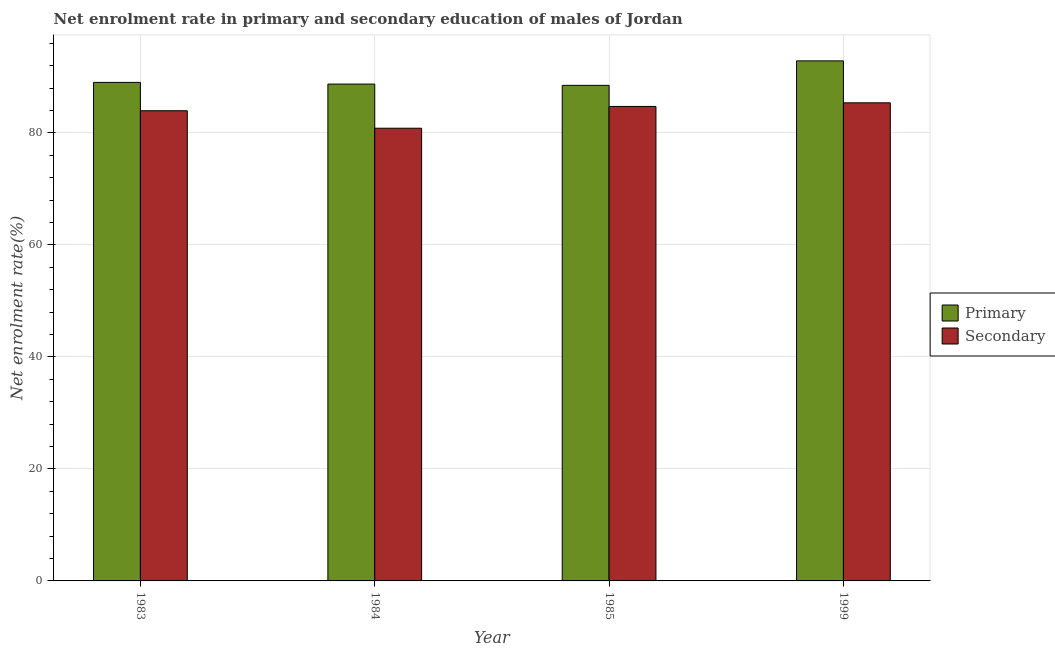How many different coloured bars are there?
Your answer should be compact. 2. Are the number of bars per tick equal to the number of legend labels?
Provide a short and direct response. Yes. What is the enrollment rate in primary education in 1984?
Ensure brevity in your answer.  88.72. Across all years, what is the maximum enrollment rate in secondary education?
Ensure brevity in your answer.  85.38. Across all years, what is the minimum enrollment rate in primary education?
Your response must be concise. 88.5. In which year was the enrollment rate in primary education maximum?
Ensure brevity in your answer.  1999. In which year was the enrollment rate in secondary education minimum?
Ensure brevity in your answer.  1984. What is the total enrollment rate in primary education in the graph?
Provide a short and direct response. 359.11. What is the difference between the enrollment rate in secondary education in 1983 and that in 1984?
Offer a very short reply. 3.12. What is the difference between the enrollment rate in primary education in 1984 and the enrollment rate in secondary education in 1983?
Your answer should be compact. -0.3. What is the average enrollment rate in secondary education per year?
Ensure brevity in your answer.  83.73. In how many years, is the enrollment rate in primary education greater than 92 %?
Ensure brevity in your answer.  1. What is the ratio of the enrollment rate in secondary education in 1984 to that in 1999?
Keep it short and to the point. 0.95. Is the difference between the enrollment rate in secondary education in 1983 and 1984 greater than the difference between the enrollment rate in primary education in 1983 and 1984?
Your answer should be compact. No. What is the difference between the highest and the second highest enrollment rate in secondary education?
Your response must be concise. 0.65. What is the difference between the highest and the lowest enrollment rate in primary education?
Make the answer very short. 4.37. In how many years, is the enrollment rate in secondary education greater than the average enrollment rate in secondary education taken over all years?
Offer a very short reply. 3. What does the 1st bar from the left in 1983 represents?
Provide a short and direct response. Primary. What does the 2nd bar from the right in 1983 represents?
Keep it short and to the point. Primary. How many bars are there?
Provide a succinct answer. 8. What is the difference between two consecutive major ticks on the Y-axis?
Your response must be concise. 20. Does the graph contain grids?
Offer a very short reply. Yes. How many legend labels are there?
Give a very brief answer. 2. What is the title of the graph?
Give a very brief answer. Net enrolment rate in primary and secondary education of males of Jordan. Does "Highest 10% of population" appear as one of the legend labels in the graph?
Ensure brevity in your answer.  No. What is the label or title of the X-axis?
Provide a short and direct response. Year. What is the label or title of the Y-axis?
Ensure brevity in your answer.  Net enrolment rate(%). What is the Net enrolment rate(%) of Primary in 1983?
Your answer should be very brief. 89.03. What is the Net enrolment rate(%) in Secondary in 1983?
Your answer should be very brief. 83.96. What is the Net enrolment rate(%) of Primary in 1984?
Keep it short and to the point. 88.72. What is the Net enrolment rate(%) in Secondary in 1984?
Make the answer very short. 80.84. What is the Net enrolment rate(%) of Primary in 1985?
Provide a succinct answer. 88.5. What is the Net enrolment rate(%) in Secondary in 1985?
Offer a very short reply. 84.73. What is the Net enrolment rate(%) in Primary in 1999?
Make the answer very short. 92.87. What is the Net enrolment rate(%) of Secondary in 1999?
Your response must be concise. 85.38. Across all years, what is the maximum Net enrolment rate(%) of Primary?
Give a very brief answer. 92.87. Across all years, what is the maximum Net enrolment rate(%) of Secondary?
Make the answer very short. 85.38. Across all years, what is the minimum Net enrolment rate(%) in Primary?
Provide a succinct answer. 88.5. Across all years, what is the minimum Net enrolment rate(%) in Secondary?
Ensure brevity in your answer.  80.84. What is the total Net enrolment rate(%) in Primary in the graph?
Offer a terse response. 359.11. What is the total Net enrolment rate(%) of Secondary in the graph?
Keep it short and to the point. 334.91. What is the difference between the Net enrolment rate(%) of Primary in 1983 and that in 1984?
Your answer should be compact. 0.3. What is the difference between the Net enrolment rate(%) in Secondary in 1983 and that in 1984?
Offer a very short reply. 3.12. What is the difference between the Net enrolment rate(%) in Primary in 1983 and that in 1985?
Your answer should be very brief. 0.53. What is the difference between the Net enrolment rate(%) of Secondary in 1983 and that in 1985?
Make the answer very short. -0.77. What is the difference between the Net enrolment rate(%) of Primary in 1983 and that in 1999?
Keep it short and to the point. -3.84. What is the difference between the Net enrolment rate(%) of Secondary in 1983 and that in 1999?
Your response must be concise. -1.41. What is the difference between the Net enrolment rate(%) in Primary in 1984 and that in 1985?
Your response must be concise. 0.23. What is the difference between the Net enrolment rate(%) of Secondary in 1984 and that in 1985?
Provide a short and direct response. -3.89. What is the difference between the Net enrolment rate(%) in Primary in 1984 and that in 1999?
Your answer should be compact. -4.14. What is the difference between the Net enrolment rate(%) of Secondary in 1984 and that in 1999?
Provide a short and direct response. -4.54. What is the difference between the Net enrolment rate(%) in Primary in 1985 and that in 1999?
Offer a terse response. -4.37. What is the difference between the Net enrolment rate(%) in Secondary in 1985 and that in 1999?
Ensure brevity in your answer.  -0.65. What is the difference between the Net enrolment rate(%) of Primary in 1983 and the Net enrolment rate(%) of Secondary in 1984?
Make the answer very short. 8.19. What is the difference between the Net enrolment rate(%) in Primary in 1983 and the Net enrolment rate(%) in Secondary in 1985?
Provide a succinct answer. 4.3. What is the difference between the Net enrolment rate(%) in Primary in 1983 and the Net enrolment rate(%) in Secondary in 1999?
Ensure brevity in your answer.  3.65. What is the difference between the Net enrolment rate(%) of Primary in 1984 and the Net enrolment rate(%) of Secondary in 1985?
Make the answer very short. 3.99. What is the difference between the Net enrolment rate(%) of Primary in 1984 and the Net enrolment rate(%) of Secondary in 1999?
Provide a succinct answer. 3.35. What is the difference between the Net enrolment rate(%) in Primary in 1985 and the Net enrolment rate(%) in Secondary in 1999?
Offer a terse response. 3.12. What is the average Net enrolment rate(%) of Primary per year?
Provide a short and direct response. 89.78. What is the average Net enrolment rate(%) of Secondary per year?
Your answer should be very brief. 83.73. In the year 1983, what is the difference between the Net enrolment rate(%) in Primary and Net enrolment rate(%) in Secondary?
Your response must be concise. 5.06. In the year 1984, what is the difference between the Net enrolment rate(%) in Primary and Net enrolment rate(%) in Secondary?
Provide a succinct answer. 7.88. In the year 1985, what is the difference between the Net enrolment rate(%) of Primary and Net enrolment rate(%) of Secondary?
Offer a terse response. 3.77. In the year 1999, what is the difference between the Net enrolment rate(%) of Primary and Net enrolment rate(%) of Secondary?
Your response must be concise. 7.49. What is the ratio of the Net enrolment rate(%) in Primary in 1983 to that in 1984?
Give a very brief answer. 1. What is the ratio of the Net enrolment rate(%) of Secondary in 1983 to that in 1984?
Give a very brief answer. 1.04. What is the ratio of the Net enrolment rate(%) of Primary in 1983 to that in 1985?
Keep it short and to the point. 1.01. What is the ratio of the Net enrolment rate(%) of Secondary in 1983 to that in 1985?
Your answer should be very brief. 0.99. What is the ratio of the Net enrolment rate(%) in Primary in 1983 to that in 1999?
Your answer should be compact. 0.96. What is the ratio of the Net enrolment rate(%) in Secondary in 1983 to that in 1999?
Your response must be concise. 0.98. What is the ratio of the Net enrolment rate(%) of Secondary in 1984 to that in 1985?
Your response must be concise. 0.95. What is the ratio of the Net enrolment rate(%) in Primary in 1984 to that in 1999?
Give a very brief answer. 0.96. What is the ratio of the Net enrolment rate(%) of Secondary in 1984 to that in 1999?
Ensure brevity in your answer.  0.95. What is the ratio of the Net enrolment rate(%) in Primary in 1985 to that in 1999?
Your answer should be very brief. 0.95. What is the difference between the highest and the second highest Net enrolment rate(%) in Primary?
Provide a succinct answer. 3.84. What is the difference between the highest and the second highest Net enrolment rate(%) of Secondary?
Provide a short and direct response. 0.65. What is the difference between the highest and the lowest Net enrolment rate(%) of Primary?
Make the answer very short. 4.37. What is the difference between the highest and the lowest Net enrolment rate(%) of Secondary?
Provide a succinct answer. 4.54. 